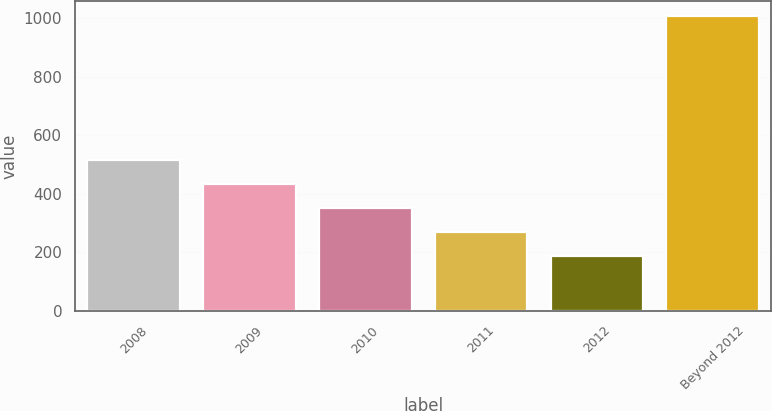Convert chart to OTSL. <chart><loc_0><loc_0><loc_500><loc_500><bar_chart><fcel>2008<fcel>2009<fcel>2010<fcel>2011<fcel>2012<fcel>Beyond 2012<nl><fcel>514.8<fcel>432.6<fcel>350.4<fcel>268.2<fcel>186<fcel>1008<nl></chart> 